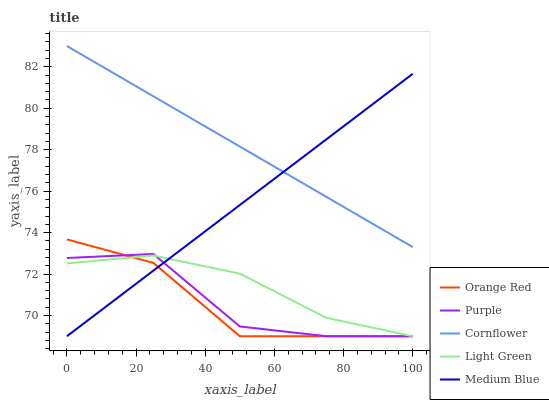Does Orange Red have the minimum area under the curve?
Answer yes or no. Yes. Does Cornflower have the maximum area under the curve?
Answer yes or no. Yes. Does Medium Blue have the minimum area under the curve?
Answer yes or no. No. Does Medium Blue have the maximum area under the curve?
Answer yes or no. No. Is Medium Blue the smoothest?
Answer yes or no. Yes. Is Purple the roughest?
Answer yes or no. Yes. Is Cornflower the smoothest?
Answer yes or no. No. Is Cornflower the roughest?
Answer yes or no. No. Does Purple have the lowest value?
Answer yes or no. Yes. Does Cornflower have the lowest value?
Answer yes or no. No. Does Cornflower have the highest value?
Answer yes or no. Yes. Does Medium Blue have the highest value?
Answer yes or no. No. Is Light Green less than Cornflower?
Answer yes or no. Yes. Is Cornflower greater than Light Green?
Answer yes or no. Yes. Does Medium Blue intersect Orange Red?
Answer yes or no. Yes. Is Medium Blue less than Orange Red?
Answer yes or no. No. Is Medium Blue greater than Orange Red?
Answer yes or no. No. Does Light Green intersect Cornflower?
Answer yes or no. No. 